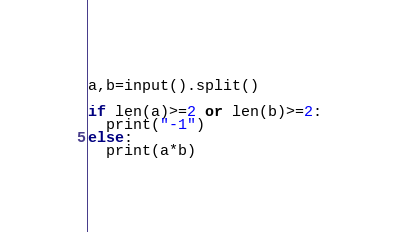<code> <loc_0><loc_0><loc_500><loc_500><_Python_>a,b=input().split()

if len(a)>=2 or len(b)>=2:
  print("-1")
else:
  print(a*b)</code> 